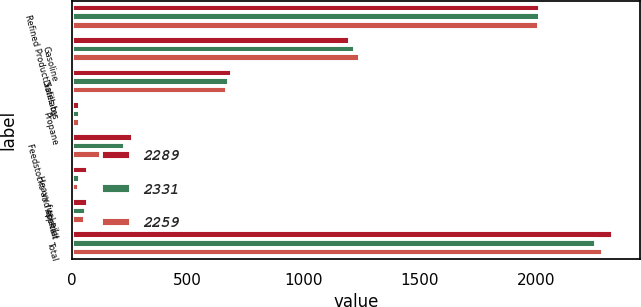<chart> <loc_0><loc_0><loc_500><loc_500><stacked_bar_chart><ecel><fcel>Refined Product Sales by<fcel>Gasoline<fcel>Distillates<fcel>Propane<fcel>Feedstocks and special<fcel>Heavy fuel oil<fcel>Asphalt<fcel>Total<nl><fcel>2289<fcel>2017<fcel>1201<fcel>691<fcel>37<fcel>265<fcel>69<fcel>68<fcel>2331<nl><fcel>2331<fcel>2016<fcel>1219<fcel>676<fcel>35<fcel>231<fcel>35<fcel>63<fcel>2259<nl><fcel>2259<fcel>2015<fcel>1241<fcel>667<fcel>36<fcel>258<fcel>30<fcel>57<fcel>2289<nl></chart> 